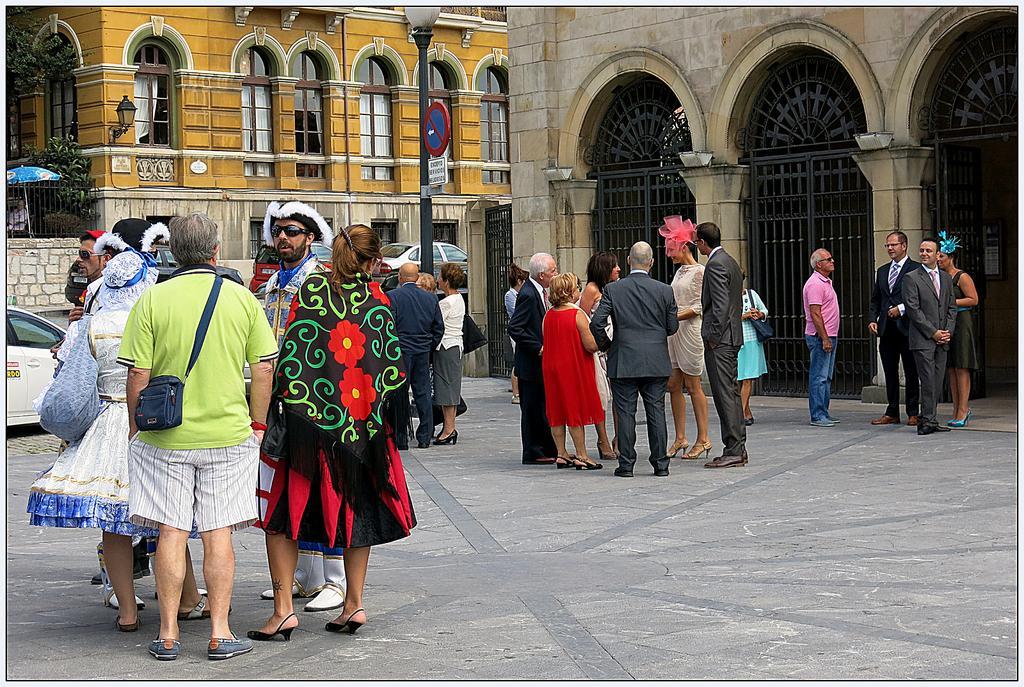Can you describe this image briefly? In the image we can see there are many people around, they are standing wearing clothes and some of them are wearing hats. This is a handbag and there are vehicles. We can even see there are buildings and these are the windows of the building. There is a gate, light pole, tree and footpath. 